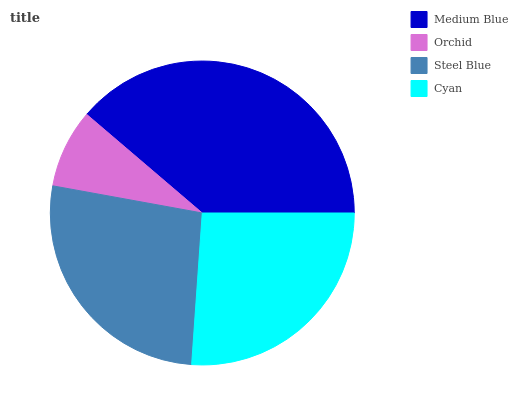Is Orchid the minimum?
Answer yes or no. Yes. Is Medium Blue the maximum?
Answer yes or no. Yes. Is Steel Blue the minimum?
Answer yes or no. No. Is Steel Blue the maximum?
Answer yes or no. No. Is Steel Blue greater than Orchid?
Answer yes or no. Yes. Is Orchid less than Steel Blue?
Answer yes or no. Yes. Is Orchid greater than Steel Blue?
Answer yes or no. No. Is Steel Blue less than Orchid?
Answer yes or no. No. Is Steel Blue the high median?
Answer yes or no. Yes. Is Cyan the low median?
Answer yes or no. Yes. Is Orchid the high median?
Answer yes or no. No. Is Steel Blue the low median?
Answer yes or no. No. 